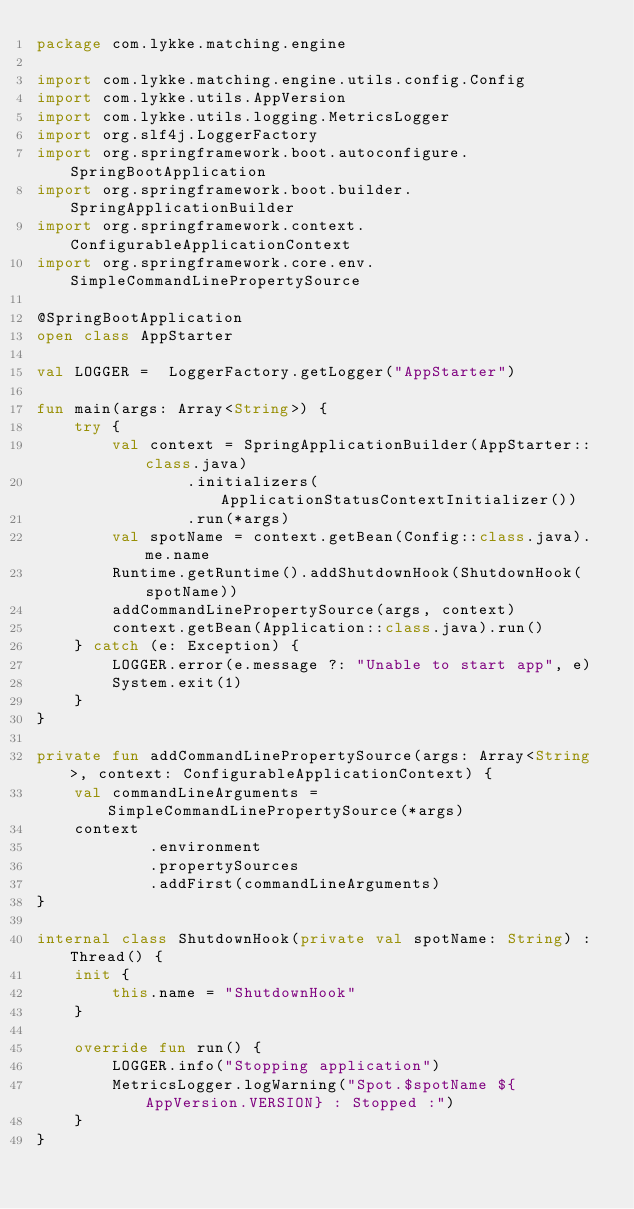<code> <loc_0><loc_0><loc_500><loc_500><_Kotlin_>package com.lykke.matching.engine

import com.lykke.matching.engine.utils.config.Config
import com.lykke.utils.AppVersion
import com.lykke.utils.logging.MetricsLogger
import org.slf4j.LoggerFactory
import org.springframework.boot.autoconfigure.SpringBootApplication
import org.springframework.boot.builder.SpringApplicationBuilder
import org.springframework.context.ConfigurableApplicationContext
import org.springframework.core.env.SimpleCommandLinePropertySource

@SpringBootApplication
open class AppStarter

val LOGGER =  LoggerFactory.getLogger("AppStarter")

fun main(args: Array<String>) {
    try {
        val context = SpringApplicationBuilder(AppStarter::class.java)
                .initializers(ApplicationStatusContextInitializer())
                .run(*args)
        val spotName = context.getBean(Config::class.java).me.name
        Runtime.getRuntime().addShutdownHook(ShutdownHook(spotName))
        addCommandLinePropertySource(args, context)
        context.getBean(Application::class.java).run()
    } catch (e: Exception) {
        LOGGER.error(e.message ?: "Unable to start app", e)
        System.exit(1)
    }
}

private fun addCommandLinePropertySource(args: Array<String>, context: ConfigurableApplicationContext) {
    val commandLineArguments = SimpleCommandLinePropertySource(*args)
    context
            .environment
            .propertySources
            .addFirst(commandLineArguments)
}

internal class ShutdownHook(private val spotName: String) : Thread() {
    init {
        this.name = "ShutdownHook"
    }

    override fun run() {
        LOGGER.info("Stopping application")
        MetricsLogger.logWarning("Spot.$spotName ${AppVersion.VERSION} : Stopped :")
    }
}


</code> 